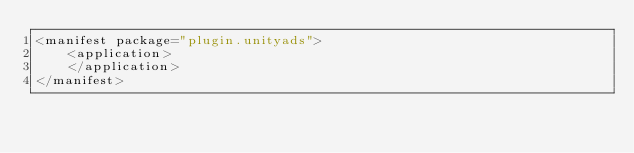<code> <loc_0><loc_0><loc_500><loc_500><_XML_><manifest package="plugin.unityads">
    <application>
    </application>
</manifest>
</code> 